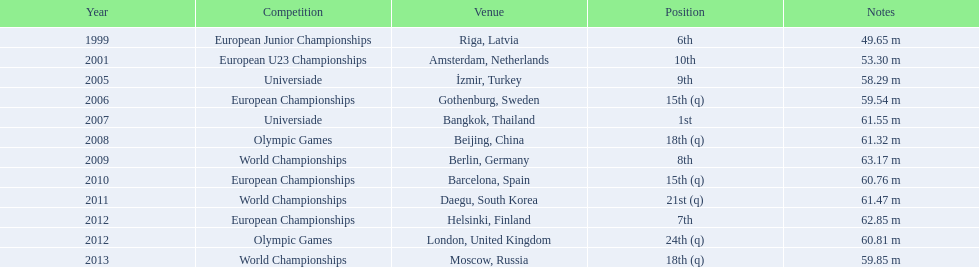Which years saw gerhard mayer's participation? 1999, 2001, 2005, 2006, 2007, 2008, 2009, 2010, 2011, 2012, 2012, 2013. From those years, which ones preceded 2007? 1999, 2001, 2005, 2006. What was the best ranking achieved in those earlier years? 6th. 